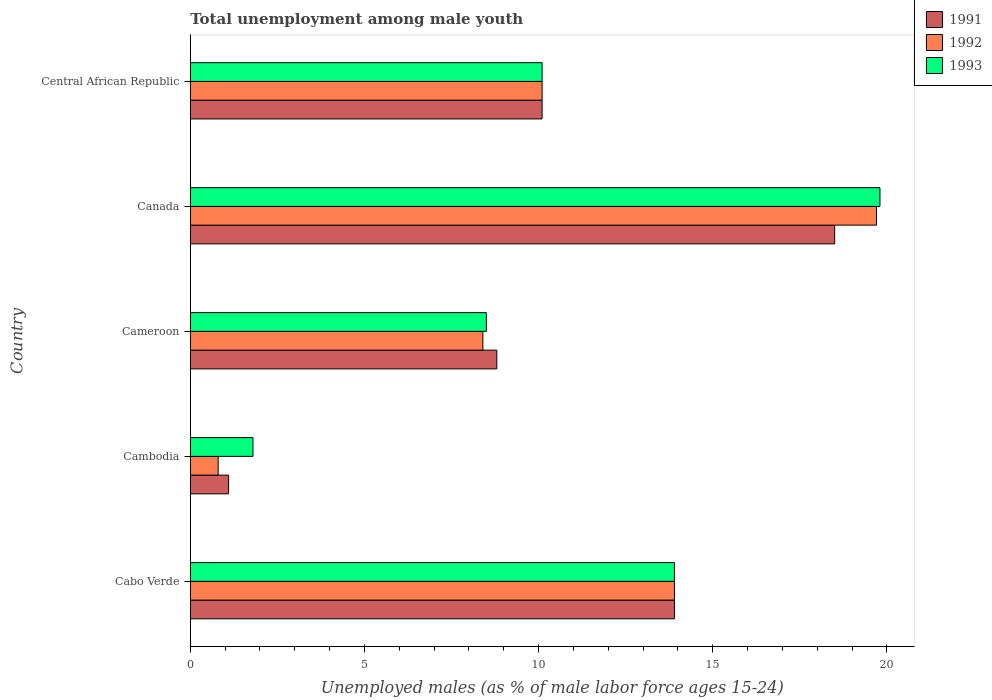How many different coloured bars are there?
Your response must be concise. 3. How many groups of bars are there?
Your answer should be compact. 5. Are the number of bars per tick equal to the number of legend labels?
Give a very brief answer. Yes. How many bars are there on the 5th tick from the top?
Your answer should be very brief. 3. How many bars are there on the 1st tick from the bottom?
Make the answer very short. 3. What is the label of the 1st group of bars from the top?
Your response must be concise. Central African Republic. In how many cases, is the number of bars for a given country not equal to the number of legend labels?
Offer a very short reply. 0. What is the percentage of unemployed males in in 1992 in Cambodia?
Offer a very short reply. 0.8. Across all countries, what is the minimum percentage of unemployed males in in 1992?
Make the answer very short. 0.8. In which country was the percentage of unemployed males in in 1992 minimum?
Give a very brief answer. Cambodia. What is the total percentage of unemployed males in in 1992 in the graph?
Your answer should be very brief. 52.9. What is the difference between the percentage of unemployed males in in 1993 in Cabo Verde and that in Cameroon?
Your answer should be very brief. 5.4. What is the difference between the percentage of unemployed males in in 1991 in Central African Republic and the percentage of unemployed males in in 1992 in Cameroon?
Your answer should be compact. 1.7. What is the average percentage of unemployed males in in 1991 per country?
Your answer should be compact. 10.48. What is the difference between the percentage of unemployed males in in 1991 and percentage of unemployed males in in 1993 in Canada?
Offer a very short reply. -1.3. In how many countries, is the percentage of unemployed males in in 1992 greater than 3 %?
Your response must be concise. 4. What is the ratio of the percentage of unemployed males in in 1993 in Cabo Verde to that in Canada?
Provide a short and direct response. 0.7. Is the percentage of unemployed males in in 1992 in Cabo Verde less than that in Cambodia?
Keep it short and to the point. No. What is the difference between the highest and the second highest percentage of unemployed males in in 1991?
Your answer should be compact. 4.6. What is the difference between the highest and the lowest percentage of unemployed males in in 1991?
Give a very brief answer. 17.4. What does the 3rd bar from the top in Canada represents?
Your answer should be compact. 1991. Is it the case that in every country, the sum of the percentage of unemployed males in in 1992 and percentage of unemployed males in in 1991 is greater than the percentage of unemployed males in in 1993?
Your response must be concise. Yes. Are all the bars in the graph horizontal?
Your response must be concise. Yes. How many countries are there in the graph?
Give a very brief answer. 5. Are the values on the major ticks of X-axis written in scientific E-notation?
Provide a succinct answer. No. Does the graph contain grids?
Provide a short and direct response. No. What is the title of the graph?
Ensure brevity in your answer.  Total unemployment among male youth. Does "1968" appear as one of the legend labels in the graph?
Provide a succinct answer. No. What is the label or title of the X-axis?
Your answer should be very brief. Unemployed males (as % of male labor force ages 15-24). What is the label or title of the Y-axis?
Your answer should be compact. Country. What is the Unemployed males (as % of male labor force ages 15-24) in 1991 in Cabo Verde?
Ensure brevity in your answer.  13.9. What is the Unemployed males (as % of male labor force ages 15-24) of 1992 in Cabo Verde?
Provide a short and direct response. 13.9. What is the Unemployed males (as % of male labor force ages 15-24) in 1993 in Cabo Verde?
Your response must be concise. 13.9. What is the Unemployed males (as % of male labor force ages 15-24) in 1991 in Cambodia?
Your response must be concise. 1.1. What is the Unemployed males (as % of male labor force ages 15-24) of 1992 in Cambodia?
Your answer should be compact. 0.8. What is the Unemployed males (as % of male labor force ages 15-24) of 1993 in Cambodia?
Make the answer very short. 1.8. What is the Unemployed males (as % of male labor force ages 15-24) of 1991 in Cameroon?
Your answer should be very brief. 8.8. What is the Unemployed males (as % of male labor force ages 15-24) in 1992 in Cameroon?
Ensure brevity in your answer.  8.4. What is the Unemployed males (as % of male labor force ages 15-24) in 1992 in Canada?
Your answer should be very brief. 19.7. What is the Unemployed males (as % of male labor force ages 15-24) in 1993 in Canada?
Offer a terse response. 19.8. What is the Unemployed males (as % of male labor force ages 15-24) of 1991 in Central African Republic?
Offer a terse response. 10.1. What is the Unemployed males (as % of male labor force ages 15-24) of 1992 in Central African Republic?
Your answer should be very brief. 10.1. What is the Unemployed males (as % of male labor force ages 15-24) of 1993 in Central African Republic?
Provide a succinct answer. 10.1. Across all countries, what is the maximum Unemployed males (as % of male labor force ages 15-24) in 1991?
Provide a succinct answer. 18.5. Across all countries, what is the maximum Unemployed males (as % of male labor force ages 15-24) of 1992?
Provide a succinct answer. 19.7. Across all countries, what is the maximum Unemployed males (as % of male labor force ages 15-24) in 1993?
Provide a short and direct response. 19.8. Across all countries, what is the minimum Unemployed males (as % of male labor force ages 15-24) of 1991?
Your response must be concise. 1.1. Across all countries, what is the minimum Unemployed males (as % of male labor force ages 15-24) in 1992?
Offer a very short reply. 0.8. Across all countries, what is the minimum Unemployed males (as % of male labor force ages 15-24) in 1993?
Your response must be concise. 1.8. What is the total Unemployed males (as % of male labor force ages 15-24) in 1991 in the graph?
Provide a short and direct response. 52.4. What is the total Unemployed males (as % of male labor force ages 15-24) of 1992 in the graph?
Offer a very short reply. 52.9. What is the total Unemployed males (as % of male labor force ages 15-24) of 1993 in the graph?
Give a very brief answer. 54.1. What is the difference between the Unemployed males (as % of male labor force ages 15-24) of 1992 in Cabo Verde and that in Cameroon?
Your response must be concise. 5.5. What is the difference between the Unemployed males (as % of male labor force ages 15-24) in 1993 in Cabo Verde and that in Cameroon?
Keep it short and to the point. 5.4. What is the difference between the Unemployed males (as % of male labor force ages 15-24) of 1991 in Cabo Verde and that in Canada?
Provide a short and direct response. -4.6. What is the difference between the Unemployed males (as % of male labor force ages 15-24) in 1992 in Cabo Verde and that in Canada?
Keep it short and to the point. -5.8. What is the difference between the Unemployed males (as % of male labor force ages 15-24) in 1993 in Cabo Verde and that in Canada?
Your answer should be compact. -5.9. What is the difference between the Unemployed males (as % of male labor force ages 15-24) of 1991 in Cabo Verde and that in Central African Republic?
Provide a short and direct response. 3.8. What is the difference between the Unemployed males (as % of male labor force ages 15-24) in 1991 in Cambodia and that in Cameroon?
Ensure brevity in your answer.  -7.7. What is the difference between the Unemployed males (as % of male labor force ages 15-24) in 1991 in Cambodia and that in Canada?
Offer a very short reply. -17.4. What is the difference between the Unemployed males (as % of male labor force ages 15-24) in 1992 in Cambodia and that in Canada?
Ensure brevity in your answer.  -18.9. What is the difference between the Unemployed males (as % of male labor force ages 15-24) of 1991 in Cambodia and that in Central African Republic?
Your answer should be very brief. -9. What is the difference between the Unemployed males (as % of male labor force ages 15-24) in 1993 in Cambodia and that in Central African Republic?
Ensure brevity in your answer.  -8.3. What is the difference between the Unemployed males (as % of male labor force ages 15-24) of 1992 in Cameroon and that in Central African Republic?
Make the answer very short. -1.7. What is the difference between the Unemployed males (as % of male labor force ages 15-24) of 1992 in Canada and that in Central African Republic?
Give a very brief answer. 9.6. What is the difference between the Unemployed males (as % of male labor force ages 15-24) in 1993 in Canada and that in Central African Republic?
Your answer should be very brief. 9.7. What is the difference between the Unemployed males (as % of male labor force ages 15-24) in 1992 in Cabo Verde and the Unemployed males (as % of male labor force ages 15-24) in 1993 in Cambodia?
Provide a short and direct response. 12.1. What is the difference between the Unemployed males (as % of male labor force ages 15-24) of 1991 in Cabo Verde and the Unemployed males (as % of male labor force ages 15-24) of 1992 in Cameroon?
Give a very brief answer. 5.5. What is the difference between the Unemployed males (as % of male labor force ages 15-24) of 1991 in Cabo Verde and the Unemployed males (as % of male labor force ages 15-24) of 1993 in Cameroon?
Keep it short and to the point. 5.4. What is the difference between the Unemployed males (as % of male labor force ages 15-24) of 1992 in Cabo Verde and the Unemployed males (as % of male labor force ages 15-24) of 1993 in Cameroon?
Provide a short and direct response. 5.4. What is the difference between the Unemployed males (as % of male labor force ages 15-24) of 1991 in Cabo Verde and the Unemployed males (as % of male labor force ages 15-24) of 1992 in Canada?
Offer a terse response. -5.8. What is the difference between the Unemployed males (as % of male labor force ages 15-24) in 1991 in Cabo Verde and the Unemployed males (as % of male labor force ages 15-24) in 1993 in Canada?
Offer a terse response. -5.9. What is the difference between the Unemployed males (as % of male labor force ages 15-24) of 1992 in Cabo Verde and the Unemployed males (as % of male labor force ages 15-24) of 1993 in Canada?
Offer a very short reply. -5.9. What is the difference between the Unemployed males (as % of male labor force ages 15-24) in 1991 in Cabo Verde and the Unemployed males (as % of male labor force ages 15-24) in 1992 in Central African Republic?
Offer a terse response. 3.8. What is the difference between the Unemployed males (as % of male labor force ages 15-24) in 1991 in Cabo Verde and the Unemployed males (as % of male labor force ages 15-24) in 1993 in Central African Republic?
Make the answer very short. 3.8. What is the difference between the Unemployed males (as % of male labor force ages 15-24) of 1991 in Cambodia and the Unemployed males (as % of male labor force ages 15-24) of 1992 in Canada?
Make the answer very short. -18.6. What is the difference between the Unemployed males (as % of male labor force ages 15-24) of 1991 in Cambodia and the Unemployed males (as % of male labor force ages 15-24) of 1993 in Canada?
Provide a short and direct response. -18.7. What is the difference between the Unemployed males (as % of male labor force ages 15-24) of 1992 in Cambodia and the Unemployed males (as % of male labor force ages 15-24) of 1993 in Canada?
Ensure brevity in your answer.  -19. What is the difference between the Unemployed males (as % of male labor force ages 15-24) of 1991 in Cambodia and the Unemployed males (as % of male labor force ages 15-24) of 1993 in Central African Republic?
Offer a very short reply. -9. What is the difference between the Unemployed males (as % of male labor force ages 15-24) in 1992 in Cambodia and the Unemployed males (as % of male labor force ages 15-24) in 1993 in Central African Republic?
Keep it short and to the point. -9.3. What is the difference between the Unemployed males (as % of male labor force ages 15-24) in 1992 in Cameroon and the Unemployed males (as % of male labor force ages 15-24) in 1993 in Canada?
Your answer should be very brief. -11.4. What is the difference between the Unemployed males (as % of male labor force ages 15-24) in 1991 in Cameroon and the Unemployed males (as % of male labor force ages 15-24) in 1992 in Central African Republic?
Keep it short and to the point. -1.3. What is the difference between the Unemployed males (as % of male labor force ages 15-24) of 1991 in Cameroon and the Unemployed males (as % of male labor force ages 15-24) of 1993 in Central African Republic?
Keep it short and to the point. -1.3. What is the difference between the Unemployed males (as % of male labor force ages 15-24) in 1992 in Cameroon and the Unemployed males (as % of male labor force ages 15-24) in 1993 in Central African Republic?
Offer a very short reply. -1.7. What is the difference between the Unemployed males (as % of male labor force ages 15-24) of 1991 in Canada and the Unemployed males (as % of male labor force ages 15-24) of 1992 in Central African Republic?
Give a very brief answer. 8.4. What is the difference between the Unemployed males (as % of male labor force ages 15-24) in 1991 in Canada and the Unemployed males (as % of male labor force ages 15-24) in 1993 in Central African Republic?
Give a very brief answer. 8.4. What is the average Unemployed males (as % of male labor force ages 15-24) in 1991 per country?
Make the answer very short. 10.48. What is the average Unemployed males (as % of male labor force ages 15-24) of 1992 per country?
Your answer should be very brief. 10.58. What is the average Unemployed males (as % of male labor force ages 15-24) in 1993 per country?
Keep it short and to the point. 10.82. What is the difference between the Unemployed males (as % of male labor force ages 15-24) of 1991 and Unemployed males (as % of male labor force ages 15-24) of 1992 in Cabo Verde?
Your response must be concise. 0. What is the difference between the Unemployed males (as % of male labor force ages 15-24) of 1991 and Unemployed males (as % of male labor force ages 15-24) of 1993 in Cabo Verde?
Provide a succinct answer. 0. What is the difference between the Unemployed males (as % of male labor force ages 15-24) of 1991 and Unemployed males (as % of male labor force ages 15-24) of 1993 in Cambodia?
Your answer should be very brief. -0.7. What is the difference between the Unemployed males (as % of male labor force ages 15-24) in 1992 and Unemployed males (as % of male labor force ages 15-24) in 1993 in Cambodia?
Make the answer very short. -1. What is the difference between the Unemployed males (as % of male labor force ages 15-24) of 1991 and Unemployed males (as % of male labor force ages 15-24) of 1993 in Cameroon?
Ensure brevity in your answer.  0.3. What is the difference between the Unemployed males (as % of male labor force ages 15-24) of 1991 and Unemployed males (as % of male labor force ages 15-24) of 1993 in Canada?
Your response must be concise. -1.3. What is the difference between the Unemployed males (as % of male labor force ages 15-24) of 1991 and Unemployed males (as % of male labor force ages 15-24) of 1992 in Central African Republic?
Make the answer very short. 0. What is the ratio of the Unemployed males (as % of male labor force ages 15-24) of 1991 in Cabo Verde to that in Cambodia?
Offer a very short reply. 12.64. What is the ratio of the Unemployed males (as % of male labor force ages 15-24) of 1992 in Cabo Verde to that in Cambodia?
Offer a very short reply. 17.38. What is the ratio of the Unemployed males (as % of male labor force ages 15-24) in 1993 in Cabo Verde to that in Cambodia?
Your response must be concise. 7.72. What is the ratio of the Unemployed males (as % of male labor force ages 15-24) of 1991 in Cabo Verde to that in Cameroon?
Ensure brevity in your answer.  1.58. What is the ratio of the Unemployed males (as % of male labor force ages 15-24) in 1992 in Cabo Verde to that in Cameroon?
Give a very brief answer. 1.65. What is the ratio of the Unemployed males (as % of male labor force ages 15-24) in 1993 in Cabo Verde to that in Cameroon?
Make the answer very short. 1.64. What is the ratio of the Unemployed males (as % of male labor force ages 15-24) in 1991 in Cabo Verde to that in Canada?
Offer a terse response. 0.75. What is the ratio of the Unemployed males (as % of male labor force ages 15-24) in 1992 in Cabo Verde to that in Canada?
Your answer should be compact. 0.71. What is the ratio of the Unemployed males (as % of male labor force ages 15-24) in 1993 in Cabo Verde to that in Canada?
Your response must be concise. 0.7. What is the ratio of the Unemployed males (as % of male labor force ages 15-24) in 1991 in Cabo Verde to that in Central African Republic?
Your answer should be very brief. 1.38. What is the ratio of the Unemployed males (as % of male labor force ages 15-24) of 1992 in Cabo Verde to that in Central African Republic?
Your answer should be very brief. 1.38. What is the ratio of the Unemployed males (as % of male labor force ages 15-24) in 1993 in Cabo Verde to that in Central African Republic?
Provide a succinct answer. 1.38. What is the ratio of the Unemployed males (as % of male labor force ages 15-24) of 1991 in Cambodia to that in Cameroon?
Make the answer very short. 0.12. What is the ratio of the Unemployed males (as % of male labor force ages 15-24) in 1992 in Cambodia to that in Cameroon?
Your answer should be compact. 0.1. What is the ratio of the Unemployed males (as % of male labor force ages 15-24) in 1993 in Cambodia to that in Cameroon?
Keep it short and to the point. 0.21. What is the ratio of the Unemployed males (as % of male labor force ages 15-24) of 1991 in Cambodia to that in Canada?
Your response must be concise. 0.06. What is the ratio of the Unemployed males (as % of male labor force ages 15-24) of 1992 in Cambodia to that in Canada?
Ensure brevity in your answer.  0.04. What is the ratio of the Unemployed males (as % of male labor force ages 15-24) of 1993 in Cambodia to that in Canada?
Make the answer very short. 0.09. What is the ratio of the Unemployed males (as % of male labor force ages 15-24) in 1991 in Cambodia to that in Central African Republic?
Provide a succinct answer. 0.11. What is the ratio of the Unemployed males (as % of male labor force ages 15-24) of 1992 in Cambodia to that in Central African Republic?
Provide a short and direct response. 0.08. What is the ratio of the Unemployed males (as % of male labor force ages 15-24) of 1993 in Cambodia to that in Central African Republic?
Provide a short and direct response. 0.18. What is the ratio of the Unemployed males (as % of male labor force ages 15-24) in 1991 in Cameroon to that in Canada?
Offer a very short reply. 0.48. What is the ratio of the Unemployed males (as % of male labor force ages 15-24) in 1992 in Cameroon to that in Canada?
Give a very brief answer. 0.43. What is the ratio of the Unemployed males (as % of male labor force ages 15-24) of 1993 in Cameroon to that in Canada?
Make the answer very short. 0.43. What is the ratio of the Unemployed males (as % of male labor force ages 15-24) in 1991 in Cameroon to that in Central African Republic?
Your answer should be very brief. 0.87. What is the ratio of the Unemployed males (as % of male labor force ages 15-24) in 1992 in Cameroon to that in Central African Republic?
Provide a succinct answer. 0.83. What is the ratio of the Unemployed males (as % of male labor force ages 15-24) in 1993 in Cameroon to that in Central African Republic?
Offer a terse response. 0.84. What is the ratio of the Unemployed males (as % of male labor force ages 15-24) of 1991 in Canada to that in Central African Republic?
Give a very brief answer. 1.83. What is the ratio of the Unemployed males (as % of male labor force ages 15-24) in 1992 in Canada to that in Central African Republic?
Your answer should be compact. 1.95. What is the ratio of the Unemployed males (as % of male labor force ages 15-24) in 1993 in Canada to that in Central African Republic?
Give a very brief answer. 1.96. What is the difference between the highest and the second highest Unemployed males (as % of male labor force ages 15-24) of 1992?
Your response must be concise. 5.8. What is the difference between the highest and the lowest Unemployed males (as % of male labor force ages 15-24) of 1992?
Give a very brief answer. 18.9. 